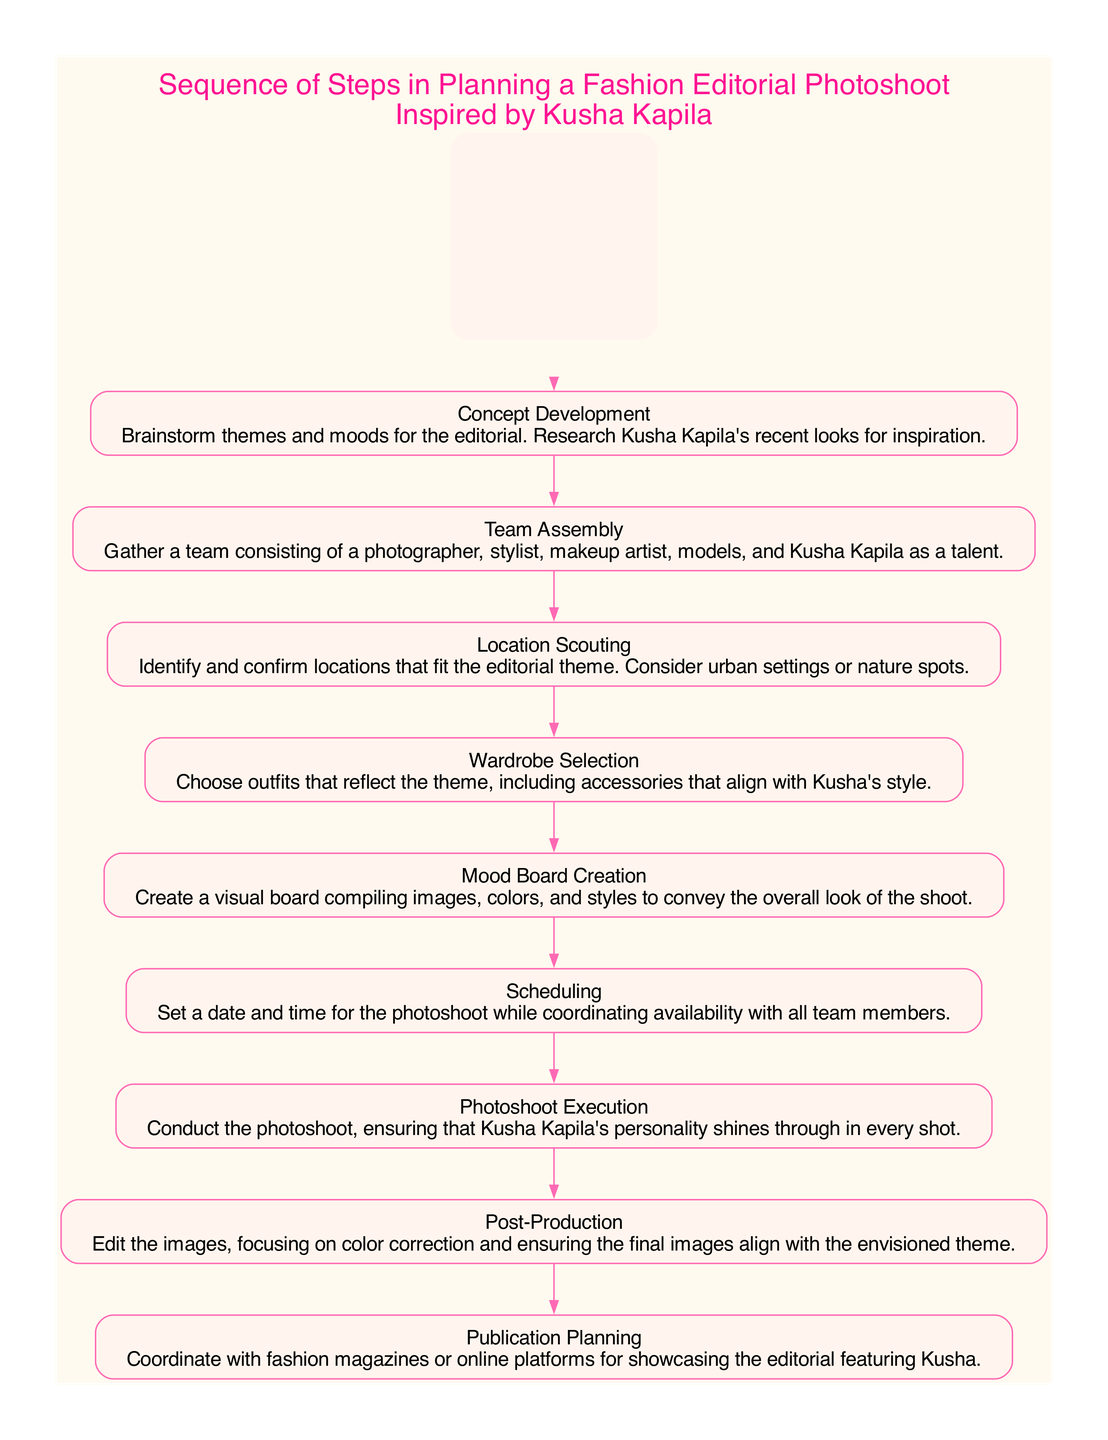What is the first step in planning a fashion editorial photoshoot? The first step in the sequence diagram is "Concept Development," which is defined as brainstorming themes and moods for the editorial.
Answer: Concept Development How many steps are there in the sequence? The diagram lists a total of nine steps involved in planning the fashion editorial photoshoot.
Answer: Nine Which step comes after "Team Assembly"? After "Team Assembly," the next step is "Location Scouting," which involves identifying and confirming suitable locations.
Answer: Location Scouting What is the last step in the sequence? The last step depicted in the diagram is "Publication Planning," which involves coordinating with magazines or online platforms for showcasing the editorial.
Answer: Publication Planning Which step involves creating a visual board? The step that involves creating a visual board is "Mood Board Creation," which compiles images, colors, and styles for the shoot.
Answer: Mood Board Creation How many visuals or elements does a mood board typically combine? A typical mood board combines images, colors, and styles to convey the overall look of the shoot, which indicates it brings together multiple visual elements.
Answer: Multiple visual elements What does the "Photoshoot Execution" step ensure? The "Photoshoot Execution" step ensures that Kusha Kapila's personality shines through in every shot taken during the photoshoot.
Answer: Kusha Kapila's personality Which step would logically follow "Post-Production"? Following "Post-Production," the logical next step in the sequence is "Publication Planning," where the focus shifts to showcasing the editorial.
Answer: Publication Planning What is the main focus during the "Post-Production" phase? The main focus during the "Post-Production" phase is editing the images, specifically on color correction and ensuring they align with the envisioned theme.
Answer: Editing images 